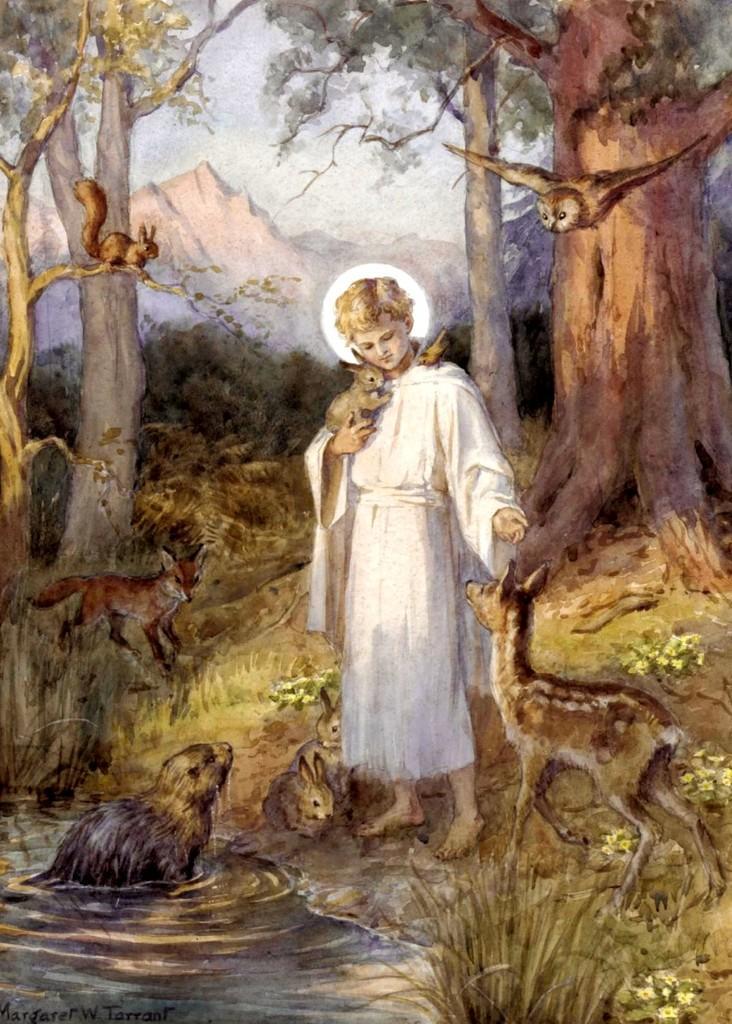How would you summarize this image in a sentence or two? It's a painting in the middle a person is standing by holding a rabbit. On the right side it's a calf and there are trees in the back side of an image. 